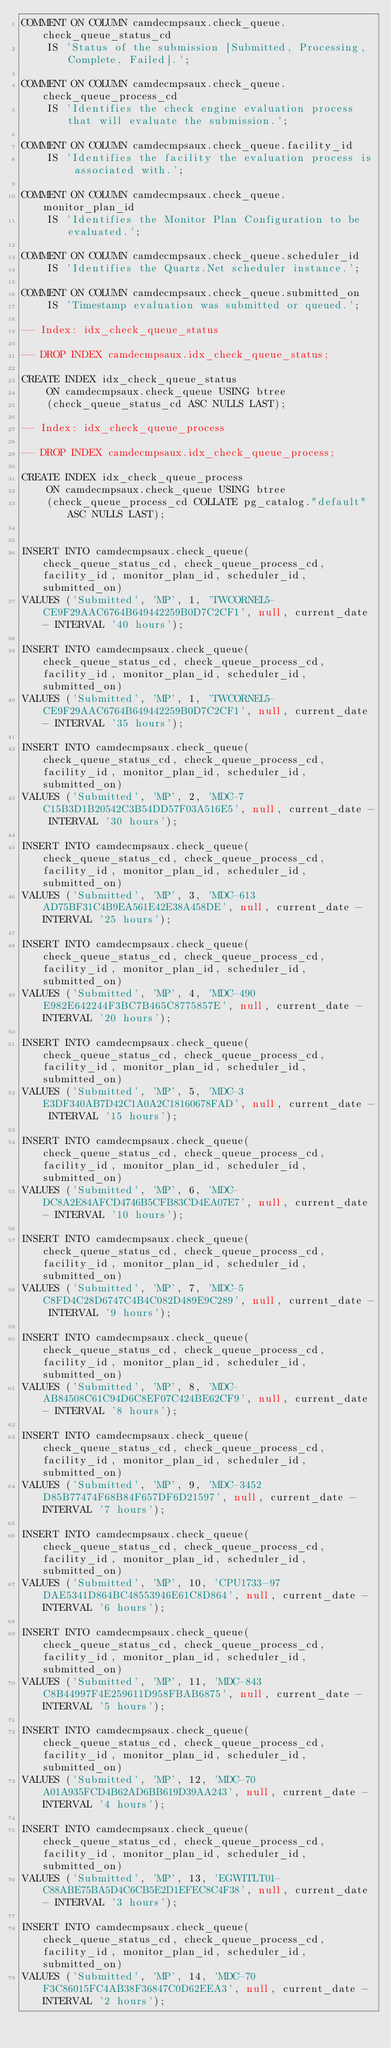<code> <loc_0><loc_0><loc_500><loc_500><_SQL_>COMMENT ON COLUMN camdecmpsaux.check_queue.check_queue_status_cd
    IS 'Status of the submission [Submitted, Processing, Complete, Failed].';

COMMENT ON COLUMN camdecmpsaux.check_queue.check_queue_process_cd
    IS 'Identifies the check engine evaluation process that will evaluate the submission.';

COMMENT ON COLUMN camdecmpsaux.check_queue.facility_id
    IS 'Identifies the facility the evaluation process is associated with.';

COMMENT ON COLUMN camdecmpsaux.check_queue.monitor_plan_id
    IS 'Identifies the Monitor Plan Configuration to be evaluated.';

COMMENT ON COLUMN camdecmpsaux.check_queue.scheduler_id
    IS 'Identifies the Quartz.Net scheduler instance.';

COMMENT ON COLUMN camdecmpsaux.check_queue.submitted_on
    IS 'Timestamp evaluation was submitted or queued.';

-- Index: idx_check_queue_status

-- DROP INDEX camdecmpsaux.idx_check_queue_status;

CREATE INDEX idx_check_queue_status
    ON camdecmpsaux.check_queue USING btree
    (check_queue_status_cd ASC NULLS LAST);

-- Index: idx_check_queue_process

-- DROP INDEX camdecmpsaux.idx_check_queue_process;

CREATE INDEX idx_check_queue_process
    ON camdecmpsaux.check_queue USING btree
    (check_queue_process_cd COLLATE pg_catalog."default" ASC NULLS LAST);


INSERT INTO camdecmpsaux.check_queue(check_queue_status_cd, check_queue_process_cd, facility_id, monitor_plan_id, scheduler_id, submitted_on)
VALUES ('Submitted', 'MP', 1, 'TWCORNEL5-CE9F29AAC6764B649442259B0D7C2CF1', null, current_date - INTERVAL '40 hours');

INSERT INTO camdecmpsaux.check_queue(check_queue_status_cd, check_queue_process_cd, facility_id, monitor_plan_id, scheduler_id, submitted_on)
VALUES ('Submitted', 'MP', 1, 'TWCORNEL5-CE9F29AAC6764B649442259B0D7C2CF1', null, current_date - INTERVAL '35 hours');

INSERT INTO camdecmpsaux.check_queue(check_queue_status_cd, check_queue_process_cd, facility_id, monitor_plan_id, scheduler_id, submitted_on)
VALUES ('Submitted', 'MP', 2, 'MDC-7C15B3D1B20542C3B54DD57F03A516E5', null, current_date - INTERVAL '30 hours');

INSERT INTO camdecmpsaux.check_queue(check_queue_status_cd, check_queue_process_cd, facility_id, monitor_plan_id, scheduler_id, submitted_on)
VALUES ('Submitted', 'MP', 3, 'MDC-613AD75BF31C4B9EA561E42E38A458DE', null, current_date - INTERVAL '25 hours');

INSERT INTO camdecmpsaux.check_queue(check_queue_status_cd, check_queue_process_cd, facility_id, monitor_plan_id, scheduler_id, submitted_on)
VALUES ('Submitted', 'MP', 4, 'MDC-490E982E642244F3BC7B465C8775857E', null, current_date - INTERVAL '20 hours');

INSERT INTO camdecmpsaux.check_queue(check_queue_status_cd, check_queue_process_cd, facility_id, monitor_plan_id, scheduler_id, submitted_on)
VALUES ('Submitted', 'MP', 5, 'MDC-3E3DF340AB7D42C1A0A2C18160678FAD', null, current_date - INTERVAL '15 hours');

INSERT INTO camdecmpsaux.check_queue(check_queue_status_cd, check_queue_process_cd, facility_id, monitor_plan_id, scheduler_id, submitted_on)
VALUES ('Submitted', 'MP', 6, 'MDC-DC8A2E84AFCD4746B5CFB83CD4EA07E7', null, current_date - INTERVAL '10 hours');

INSERT INTO camdecmpsaux.check_queue(check_queue_status_cd, check_queue_process_cd, facility_id, monitor_plan_id, scheduler_id, submitted_on)
VALUES ('Submitted', 'MP', 7, 'MDC-5C8FD4C28D6747C4B4C082D489E9C289', null, current_date - INTERVAL '9 hours');

INSERT INTO camdecmpsaux.check_queue(check_queue_status_cd, check_queue_process_cd, facility_id, monitor_plan_id, scheduler_id, submitted_on)
VALUES ('Submitted', 'MP', 8, 'MDC-AB84508C61C94D6C8EF07C424BE62CF9', null, current_date - INTERVAL '8 hours');

INSERT INTO camdecmpsaux.check_queue(check_queue_status_cd, check_queue_process_cd, facility_id, monitor_plan_id, scheduler_id, submitted_on)
VALUES ('Submitted', 'MP', 9, 'MDC-3452D85B77474F68B84F657DF6D21597', null, current_date - INTERVAL '7 hours');

INSERT INTO camdecmpsaux.check_queue(check_queue_status_cd, check_queue_process_cd, facility_id, monitor_plan_id, scheduler_id, submitted_on)
VALUES ('Submitted', 'MP', 10, 'CPU1733-97DAE5341D864BC48553946E61C8D864', null, current_date - INTERVAL '6 hours');

INSERT INTO camdecmpsaux.check_queue(check_queue_status_cd, check_queue_process_cd, facility_id, monitor_plan_id, scheduler_id, submitted_on)
VALUES ('Submitted', 'MP', 11, 'MDC-843C8B44997F4E259611D958FBAB6875', null, current_date - INTERVAL '5 hours');

INSERT INTO camdecmpsaux.check_queue(check_queue_status_cd, check_queue_process_cd, facility_id, monitor_plan_id, scheduler_id, submitted_on)
VALUES ('Submitted', 'MP', 12, 'MDC-70A01A935FCD4B62AD6BB619D39AA243', null, current_date - INTERVAL '4 hours');

INSERT INTO camdecmpsaux.check_queue(check_queue_status_cd, check_queue_process_cd, facility_id, monitor_plan_id, scheduler_id, submitted_on)
VALUES ('Submitted', 'MP', 13, 'EGWITLT01-C88ABE75BA5D4C6CB5E2D1EFEC8C4F38', null, current_date - INTERVAL '3 hours');

INSERT INTO camdecmpsaux.check_queue(check_queue_status_cd, check_queue_process_cd, facility_id, monitor_plan_id, scheduler_id, submitted_on)
VALUES ('Submitted', 'MP', 14, 'MDC-70F3C86015FC4AB38F36847C0D62EEA3', null, current_date - INTERVAL '2 hours');
</code> 